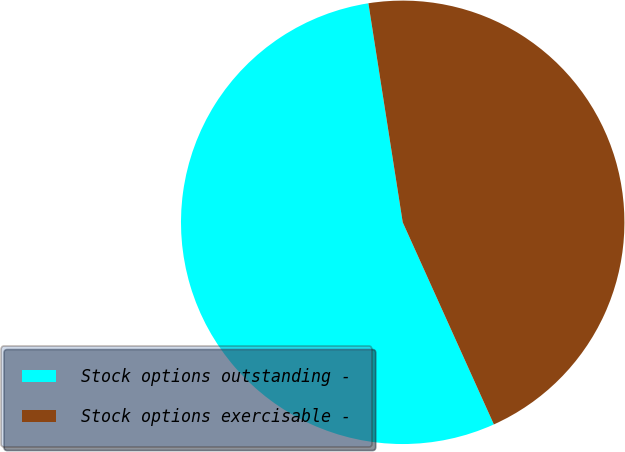<chart> <loc_0><loc_0><loc_500><loc_500><pie_chart><fcel>Stock options outstanding -<fcel>Stock options exercisable -<nl><fcel>54.27%<fcel>45.73%<nl></chart> 